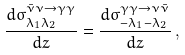<formula> <loc_0><loc_0><loc_500><loc_500>\frac { d { \sigma } ^ { \bar { \nu } \nu \to \gamma \gamma } _ { \lambda _ { 1 } \lambda _ { 2 } } } { d z } = \frac { d { \sigma } ^ { \gamma \gamma \to \nu \bar { \nu } } _ { - \lambda _ { 1 } - \lambda _ { 2 } } } { d z } \, ,</formula> 